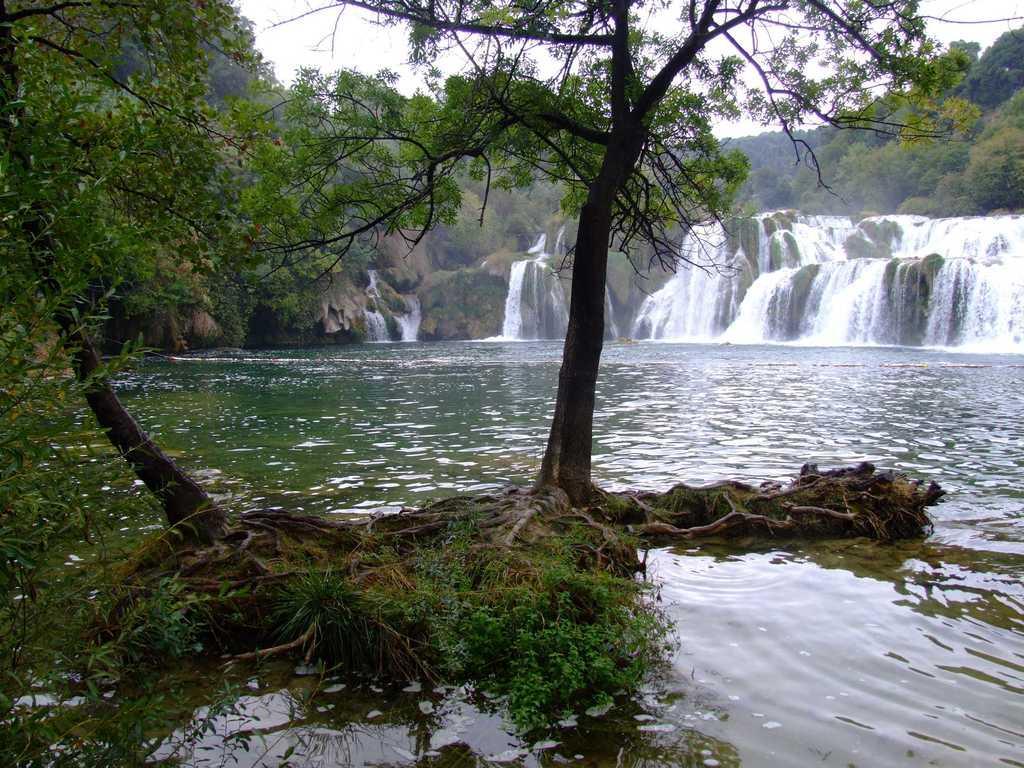Could you give a brief overview of what you see in this image? There are trees and water in the foreground area of the image, there are waterfalls, it seems like mountains and the sky in the background. 